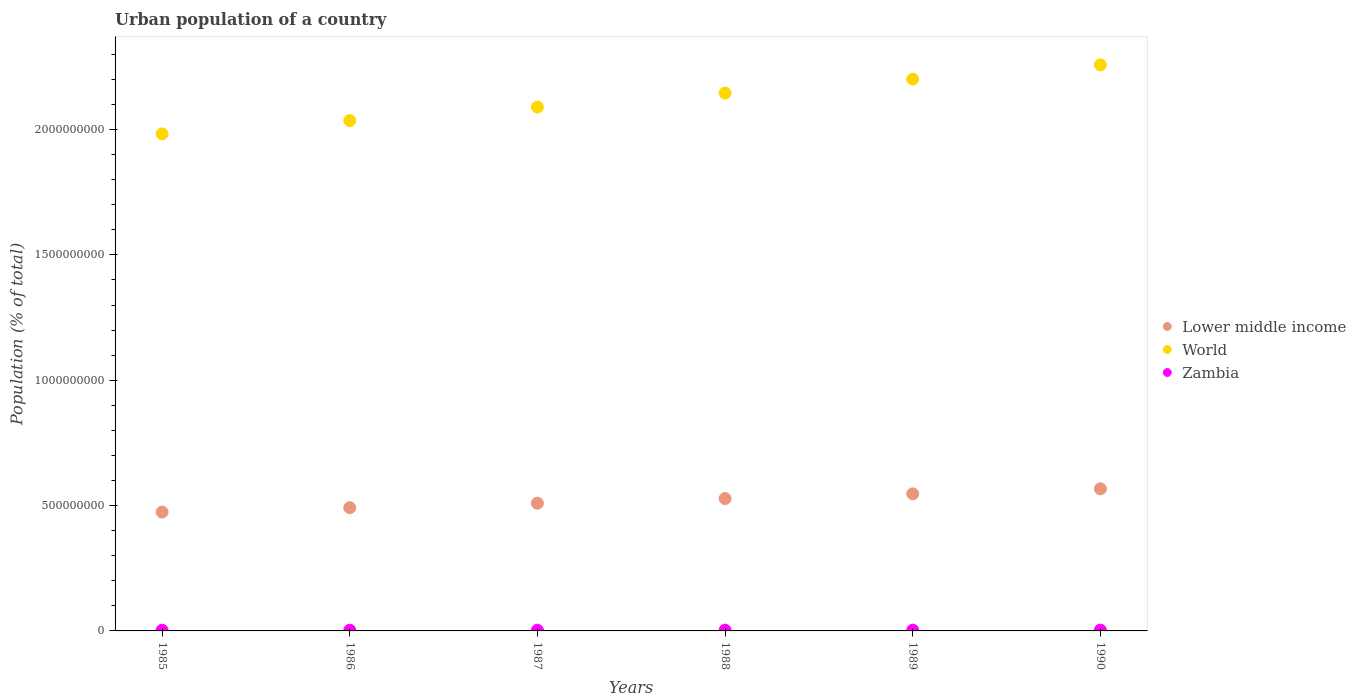How many different coloured dotlines are there?
Make the answer very short. 3. Is the number of dotlines equal to the number of legend labels?
Your response must be concise. Yes. What is the urban population in World in 1985?
Your response must be concise. 1.98e+09. Across all years, what is the maximum urban population in World?
Offer a terse response. 2.26e+09. Across all years, what is the minimum urban population in World?
Offer a terse response. 1.98e+09. In which year was the urban population in World maximum?
Provide a short and direct response. 1990. In which year was the urban population in World minimum?
Make the answer very short. 1985. What is the total urban population in Zambia in the graph?
Make the answer very short. 1.80e+07. What is the difference between the urban population in Zambia in 1985 and that in 1988?
Make the answer very short. -2.58e+05. What is the difference between the urban population in World in 1990 and the urban population in Zambia in 1987?
Provide a succinct answer. 2.26e+09. What is the average urban population in Lower middle income per year?
Make the answer very short. 5.19e+08. In the year 1988, what is the difference between the urban population in Zambia and urban population in Lower middle income?
Provide a short and direct response. -5.25e+08. In how many years, is the urban population in World greater than 2200000000 %?
Your answer should be compact. 2. What is the ratio of the urban population in World in 1985 to that in 1986?
Your answer should be very brief. 0.97. Is the urban population in Zambia in 1989 less than that in 1990?
Ensure brevity in your answer.  Yes. Is the difference between the urban population in Zambia in 1988 and 1990 greater than the difference between the urban population in Lower middle income in 1988 and 1990?
Give a very brief answer. Yes. What is the difference between the highest and the second highest urban population in World?
Provide a succinct answer. 5.70e+07. What is the difference between the highest and the lowest urban population in Lower middle income?
Keep it short and to the point. 9.26e+07. Does the urban population in Lower middle income monotonically increase over the years?
Give a very brief answer. Yes. Is the urban population in Lower middle income strictly greater than the urban population in World over the years?
Provide a succinct answer. No. How many years are there in the graph?
Provide a short and direct response. 6. Are the values on the major ticks of Y-axis written in scientific E-notation?
Your answer should be very brief. No. Does the graph contain any zero values?
Your response must be concise. No. Does the graph contain grids?
Your answer should be very brief. No. How are the legend labels stacked?
Offer a very short reply. Vertical. What is the title of the graph?
Your answer should be very brief. Urban population of a country. Does "Italy" appear as one of the legend labels in the graph?
Provide a short and direct response. No. What is the label or title of the Y-axis?
Give a very brief answer. Population (% of total). What is the Population (% of total) of Lower middle income in 1985?
Make the answer very short. 4.74e+08. What is the Population (% of total) of World in 1985?
Keep it short and to the point. 1.98e+09. What is the Population (% of total) in Zambia in 1985?
Your response must be concise. 2.78e+06. What is the Population (% of total) of Lower middle income in 1986?
Provide a succinct answer. 4.92e+08. What is the Population (% of total) of World in 1986?
Provide a succinct answer. 2.04e+09. What is the Population (% of total) in Zambia in 1986?
Provide a short and direct response. 2.87e+06. What is the Population (% of total) in Lower middle income in 1987?
Ensure brevity in your answer.  5.10e+08. What is the Population (% of total) of World in 1987?
Keep it short and to the point. 2.09e+09. What is the Population (% of total) in Zambia in 1987?
Keep it short and to the point. 2.95e+06. What is the Population (% of total) in Lower middle income in 1988?
Make the answer very short. 5.28e+08. What is the Population (% of total) in World in 1988?
Keep it short and to the point. 2.15e+09. What is the Population (% of total) of Zambia in 1988?
Ensure brevity in your answer.  3.04e+06. What is the Population (% of total) in Lower middle income in 1989?
Offer a terse response. 5.47e+08. What is the Population (% of total) in World in 1989?
Give a very brief answer. 2.20e+09. What is the Population (% of total) of Zambia in 1989?
Give a very brief answer. 3.13e+06. What is the Population (% of total) in Lower middle income in 1990?
Your answer should be compact. 5.67e+08. What is the Population (% of total) of World in 1990?
Ensure brevity in your answer.  2.26e+09. What is the Population (% of total) of Zambia in 1990?
Your answer should be compact. 3.21e+06. Across all years, what is the maximum Population (% of total) of Lower middle income?
Provide a succinct answer. 5.67e+08. Across all years, what is the maximum Population (% of total) in World?
Your answer should be very brief. 2.26e+09. Across all years, what is the maximum Population (% of total) in Zambia?
Ensure brevity in your answer.  3.21e+06. Across all years, what is the minimum Population (% of total) in Lower middle income?
Your response must be concise. 4.74e+08. Across all years, what is the minimum Population (% of total) in World?
Your answer should be compact. 1.98e+09. Across all years, what is the minimum Population (% of total) in Zambia?
Offer a terse response. 2.78e+06. What is the total Population (% of total) in Lower middle income in the graph?
Provide a succinct answer. 3.12e+09. What is the total Population (% of total) in World in the graph?
Offer a very short reply. 1.27e+1. What is the total Population (% of total) of Zambia in the graph?
Make the answer very short. 1.80e+07. What is the difference between the Population (% of total) of Lower middle income in 1985 and that in 1986?
Offer a terse response. -1.75e+07. What is the difference between the Population (% of total) of World in 1985 and that in 1986?
Provide a short and direct response. -5.29e+07. What is the difference between the Population (% of total) of Zambia in 1985 and that in 1986?
Offer a terse response. -8.58e+04. What is the difference between the Population (% of total) in Lower middle income in 1985 and that in 1987?
Offer a terse response. -3.55e+07. What is the difference between the Population (% of total) of World in 1985 and that in 1987?
Your response must be concise. -1.07e+08. What is the difference between the Population (% of total) of Zambia in 1985 and that in 1987?
Make the answer very short. -1.72e+05. What is the difference between the Population (% of total) of Lower middle income in 1985 and that in 1988?
Make the answer very short. -5.39e+07. What is the difference between the Population (% of total) of World in 1985 and that in 1988?
Your answer should be very brief. -1.63e+08. What is the difference between the Population (% of total) of Zambia in 1985 and that in 1988?
Your answer should be very brief. -2.58e+05. What is the difference between the Population (% of total) of Lower middle income in 1985 and that in 1989?
Give a very brief answer. -7.26e+07. What is the difference between the Population (% of total) in World in 1985 and that in 1989?
Offer a very short reply. -2.18e+08. What is the difference between the Population (% of total) of Zambia in 1985 and that in 1989?
Ensure brevity in your answer.  -3.43e+05. What is the difference between the Population (% of total) in Lower middle income in 1985 and that in 1990?
Provide a short and direct response. -9.26e+07. What is the difference between the Population (% of total) in World in 1985 and that in 1990?
Your answer should be very brief. -2.75e+08. What is the difference between the Population (% of total) in Zambia in 1985 and that in 1990?
Provide a short and direct response. -4.26e+05. What is the difference between the Population (% of total) in Lower middle income in 1986 and that in 1987?
Make the answer very short. -1.80e+07. What is the difference between the Population (% of total) of World in 1986 and that in 1987?
Make the answer very short. -5.40e+07. What is the difference between the Population (% of total) in Zambia in 1986 and that in 1987?
Make the answer very short. -8.61e+04. What is the difference between the Population (% of total) of Lower middle income in 1986 and that in 1988?
Your answer should be compact. -3.64e+07. What is the difference between the Population (% of total) in World in 1986 and that in 1988?
Your response must be concise. -1.10e+08. What is the difference between the Population (% of total) in Zambia in 1986 and that in 1988?
Ensure brevity in your answer.  -1.72e+05. What is the difference between the Population (% of total) of Lower middle income in 1986 and that in 1989?
Offer a terse response. -5.51e+07. What is the difference between the Population (% of total) in World in 1986 and that in 1989?
Ensure brevity in your answer.  -1.65e+08. What is the difference between the Population (% of total) in Zambia in 1986 and that in 1989?
Your response must be concise. -2.57e+05. What is the difference between the Population (% of total) in Lower middle income in 1986 and that in 1990?
Offer a terse response. -7.51e+07. What is the difference between the Population (% of total) in World in 1986 and that in 1990?
Your response must be concise. -2.22e+08. What is the difference between the Population (% of total) of Zambia in 1986 and that in 1990?
Your answer should be compact. -3.41e+05. What is the difference between the Population (% of total) in Lower middle income in 1987 and that in 1988?
Give a very brief answer. -1.84e+07. What is the difference between the Population (% of total) in World in 1987 and that in 1988?
Give a very brief answer. -5.59e+07. What is the difference between the Population (% of total) in Zambia in 1987 and that in 1988?
Make the answer very short. -8.59e+04. What is the difference between the Population (% of total) in Lower middle income in 1987 and that in 1989?
Give a very brief answer. -3.71e+07. What is the difference between the Population (% of total) in World in 1987 and that in 1989?
Your answer should be very brief. -1.11e+08. What is the difference between the Population (% of total) of Zambia in 1987 and that in 1989?
Offer a terse response. -1.71e+05. What is the difference between the Population (% of total) of Lower middle income in 1987 and that in 1990?
Your response must be concise. -5.71e+07. What is the difference between the Population (% of total) in World in 1987 and that in 1990?
Provide a short and direct response. -1.69e+08. What is the difference between the Population (% of total) of Zambia in 1987 and that in 1990?
Your answer should be compact. -2.54e+05. What is the difference between the Population (% of total) in Lower middle income in 1988 and that in 1989?
Make the answer very short. -1.87e+07. What is the difference between the Population (% of total) of World in 1988 and that in 1989?
Provide a short and direct response. -5.56e+07. What is the difference between the Population (% of total) of Zambia in 1988 and that in 1989?
Provide a short and direct response. -8.49e+04. What is the difference between the Population (% of total) of Lower middle income in 1988 and that in 1990?
Offer a very short reply. -3.87e+07. What is the difference between the Population (% of total) in World in 1988 and that in 1990?
Offer a terse response. -1.13e+08. What is the difference between the Population (% of total) in Zambia in 1988 and that in 1990?
Make the answer very short. -1.69e+05. What is the difference between the Population (% of total) of Lower middle income in 1989 and that in 1990?
Your answer should be very brief. -2.01e+07. What is the difference between the Population (% of total) of World in 1989 and that in 1990?
Make the answer very short. -5.70e+07. What is the difference between the Population (% of total) of Zambia in 1989 and that in 1990?
Your response must be concise. -8.36e+04. What is the difference between the Population (% of total) of Lower middle income in 1985 and the Population (% of total) of World in 1986?
Your response must be concise. -1.56e+09. What is the difference between the Population (% of total) in Lower middle income in 1985 and the Population (% of total) in Zambia in 1986?
Your response must be concise. 4.71e+08. What is the difference between the Population (% of total) of World in 1985 and the Population (% of total) of Zambia in 1986?
Provide a succinct answer. 1.98e+09. What is the difference between the Population (% of total) of Lower middle income in 1985 and the Population (% of total) of World in 1987?
Your answer should be very brief. -1.62e+09. What is the difference between the Population (% of total) of Lower middle income in 1985 and the Population (% of total) of Zambia in 1987?
Ensure brevity in your answer.  4.71e+08. What is the difference between the Population (% of total) of World in 1985 and the Population (% of total) of Zambia in 1987?
Your response must be concise. 1.98e+09. What is the difference between the Population (% of total) of Lower middle income in 1985 and the Population (% of total) of World in 1988?
Offer a terse response. -1.67e+09. What is the difference between the Population (% of total) in Lower middle income in 1985 and the Population (% of total) in Zambia in 1988?
Your answer should be compact. 4.71e+08. What is the difference between the Population (% of total) of World in 1985 and the Population (% of total) of Zambia in 1988?
Make the answer very short. 1.98e+09. What is the difference between the Population (% of total) of Lower middle income in 1985 and the Population (% of total) of World in 1989?
Make the answer very short. -1.73e+09. What is the difference between the Population (% of total) of Lower middle income in 1985 and the Population (% of total) of Zambia in 1989?
Your answer should be very brief. 4.71e+08. What is the difference between the Population (% of total) of World in 1985 and the Population (% of total) of Zambia in 1989?
Your answer should be compact. 1.98e+09. What is the difference between the Population (% of total) of Lower middle income in 1985 and the Population (% of total) of World in 1990?
Provide a succinct answer. -1.78e+09. What is the difference between the Population (% of total) in Lower middle income in 1985 and the Population (% of total) in Zambia in 1990?
Give a very brief answer. 4.71e+08. What is the difference between the Population (% of total) in World in 1985 and the Population (% of total) in Zambia in 1990?
Provide a short and direct response. 1.98e+09. What is the difference between the Population (% of total) of Lower middle income in 1986 and the Population (% of total) of World in 1987?
Offer a terse response. -1.60e+09. What is the difference between the Population (% of total) in Lower middle income in 1986 and the Population (% of total) in Zambia in 1987?
Offer a terse response. 4.89e+08. What is the difference between the Population (% of total) of World in 1986 and the Population (% of total) of Zambia in 1987?
Provide a succinct answer. 2.03e+09. What is the difference between the Population (% of total) in Lower middle income in 1986 and the Population (% of total) in World in 1988?
Provide a succinct answer. -1.65e+09. What is the difference between the Population (% of total) in Lower middle income in 1986 and the Population (% of total) in Zambia in 1988?
Offer a terse response. 4.89e+08. What is the difference between the Population (% of total) of World in 1986 and the Population (% of total) of Zambia in 1988?
Offer a terse response. 2.03e+09. What is the difference between the Population (% of total) in Lower middle income in 1986 and the Population (% of total) in World in 1989?
Your answer should be compact. -1.71e+09. What is the difference between the Population (% of total) of Lower middle income in 1986 and the Population (% of total) of Zambia in 1989?
Offer a very short reply. 4.88e+08. What is the difference between the Population (% of total) of World in 1986 and the Population (% of total) of Zambia in 1989?
Provide a succinct answer. 2.03e+09. What is the difference between the Population (% of total) of Lower middle income in 1986 and the Population (% of total) of World in 1990?
Your answer should be compact. -1.77e+09. What is the difference between the Population (% of total) of Lower middle income in 1986 and the Population (% of total) of Zambia in 1990?
Provide a short and direct response. 4.88e+08. What is the difference between the Population (% of total) of World in 1986 and the Population (% of total) of Zambia in 1990?
Provide a short and direct response. 2.03e+09. What is the difference between the Population (% of total) in Lower middle income in 1987 and the Population (% of total) in World in 1988?
Ensure brevity in your answer.  -1.64e+09. What is the difference between the Population (% of total) in Lower middle income in 1987 and the Population (% of total) in Zambia in 1988?
Provide a short and direct response. 5.07e+08. What is the difference between the Population (% of total) of World in 1987 and the Population (% of total) of Zambia in 1988?
Your answer should be very brief. 2.09e+09. What is the difference between the Population (% of total) in Lower middle income in 1987 and the Population (% of total) in World in 1989?
Make the answer very short. -1.69e+09. What is the difference between the Population (% of total) in Lower middle income in 1987 and the Population (% of total) in Zambia in 1989?
Give a very brief answer. 5.06e+08. What is the difference between the Population (% of total) in World in 1987 and the Population (% of total) in Zambia in 1989?
Your response must be concise. 2.09e+09. What is the difference between the Population (% of total) of Lower middle income in 1987 and the Population (% of total) of World in 1990?
Make the answer very short. -1.75e+09. What is the difference between the Population (% of total) of Lower middle income in 1987 and the Population (% of total) of Zambia in 1990?
Provide a short and direct response. 5.06e+08. What is the difference between the Population (% of total) in World in 1987 and the Population (% of total) in Zambia in 1990?
Your response must be concise. 2.09e+09. What is the difference between the Population (% of total) in Lower middle income in 1988 and the Population (% of total) in World in 1989?
Provide a succinct answer. -1.67e+09. What is the difference between the Population (% of total) in Lower middle income in 1988 and the Population (% of total) in Zambia in 1989?
Offer a very short reply. 5.25e+08. What is the difference between the Population (% of total) in World in 1988 and the Population (% of total) in Zambia in 1989?
Your response must be concise. 2.14e+09. What is the difference between the Population (% of total) in Lower middle income in 1988 and the Population (% of total) in World in 1990?
Keep it short and to the point. -1.73e+09. What is the difference between the Population (% of total) of Lower middle income in 1988 and the Population (% of total) of Zambia in 1990?
Offer a very short reply. 5.25e+08. What is the difference between the Population (% of total) of World in 1988 and the Population (% of total) of Zambia in 1990?
Your answer should be compact. 2.14e+09. What is the difference between the Population (% of total) in Lower middle income in 1989 and the Population (% of total) in World in 1990?
Offer a terse response. -1.71e+09. What is the difference between the Population (% of total) of Lower middle income in 1989 and the Population (% of total) of Zambia in 1990?
Ensure brevity in your answer.  5.43e+08. What is the difference between the Population (% of total) in World in 1989 and the Population (% of total) in Zambia in 1990?
Ensure brevity in your answer.  2.20e+09. What is the average Population (% of total) in Lower middle income per year?
Your answer should be compact. 5.19e+08. What is the average Population (% of total) in World per year?
Ensure brevity in your answer.  2.12e+09. What is the average Population (% of total) of Zambia per year?
Offer a very short reply. 3.00e+06. In the year 1985, what is the difference between the Population (% of total) in Lower middle income and Population (% of total) in World?
Keep it short and to the point. -1.51e+09. In the year 1985, what is the difference between the Population (% of total) of Lower middle income and Population (% of total) of Zambia?
Ensure brevity in your answer.  4.71e+08. In the year 1985, what is the difference between the Population (% of total) in World and Population (% of total) in Zambia?
Provide a short and direct response. 1.98e+09. In the year 1986, what is the difference between the Population (% of total) of Lower middle income and Population (% of total) of World?
Keep it short and to the point. -1.54e+09. In the year 1986, what is the difference between the Population (% of total) of Lower middle income and Population (% of total) of Zambia?
Your answer should be compact. 4.89e+08. In the year 1986, what is the difference between the Population (% of total) of World and Population (% of total) of Zambia?
Your answer should be compact. 2.03e+09. In the year 1987, what is the difference between the Population (% of total) in Lower middle income and Population (% of total) in World?
Keep it short and to the point. -1.58e+09. In the year 1987, what is the difference between the Population (% of total) in Lower middle income and Population (% of total) in Zambia?
Ensure brevity in your answer.  5.07e+08. In the year 1987, what is the difference between the Population (% of total) in World and Population (% of total) in Zambia?
Provide a short and direct response. 2.09e+09. In the year 1988, what is the difference between the Population (% of total) of Lower middle income and Population (% of total) of World?
Provide a succinct answer. -1.62e+09. In the year 1988, what is the difference between the Population (% of total) in Lower middle income and Population (% of total) in Zambia?
Your answer should be compact. 5.25e+08. In the year 1988, what is the difference between the Population (% of total) of World and Population (% of total) of Zambia?
Ensure brevity in your answer.  2.14e+09. In the year 1989, what is the difference between the Population (% of total) in Lower middle income and Population (% of total) in World?
Keep it short and to the point. -1.65e+09. In the year 1989, what is the difference between the Population (% of total) in Lower middle income and Population (% of total) in Zambia?
Provide a short and direct response. 5.44e+08. In the year 1989, what is the difference between the Population (% of total) of World and Population (% of total) of Zambia?
Ensure brevity in your answer.  2.20e+09. In the year 1990, what is the difference between the Population (% of total) in Lower middle income and Population (% of total) in World?
Your response must be concise. -1.69e+09. In the year 1990, what is the difference between the Population (% of total) of Lower middle income and Population (% of total) of Zambia?
Your answer should be very brief. 5.64e+08. In the year 1990, what is the difference between the Population (% of total) of World and Population (% of total) of Zambia?
Provide a succinct answer. 2.25e+09. What is the ratio of the Population (% of total) of Lower middle income in 1985 to that in 1986?
Offer a terse response. 0.96. What is the ratio of the Population (% of total) of World in 1985 to that in 1986?
Your response must be concise. 0.97. What is the ratio of the Population (% of total) in Zambia in 1985 to that in 1986?
Your response must be concise. 0.97. What is the ratio of the Population (% of total) of Lower middle income in 1985 to that in 1987?
Provide a succinct answer. 0.93. What is the ratio of the Population (% of total) in World in 1985 to that in 1987?
Make the answer very short. 0.95. What is the ratio of the Population (% of total) of Zambia in 1985 to that in 1987?
Give a very brief answer. 0.94. What is the ratio of the Population (% of total) in Lower middle income in 1985 to that in 1988?
Provide a succinct answer. 0.9. What is the ratio of the Population (% of total) of World in 1985 to that in 1988?
Ensure brevity in your answer.  0.92. What is the ratio of the Population (% of total) of Zambia in 1985 to that in 1988?
Your response must be concise. 0.92. What is the ratio of the Population (% of total) in Lower middle income in 1985 to that in 1989?
Offer a terse response. 0.87. What is the ratio of the Population (% of total) of World in 1985 to that in 1989?
Ensure brevity in your answer.  0.9. What is the ratio of the Population (% of total) of Zambia in 1985 to that in 1989?
Give a very brief answer. 0.89. What is the ratio of the Population (% of total) of Lower middle income in 1985 to that in 1990?
Your answer should be very brief. 0.84. What is the ratio of the Population (% of total) of World in 1985 to that in 1990?
Ensure brevity in your answer.  0.88. What is the ratio of the Population (% of total) in Zambia in 1985 to that in 1990?
Keep it short and to the point. 0.87. What is the ratio of the Population (% of total) in Lower middle income in 1986 to that in 1987?
Offer a terse response. 0.96. What is the ratio of the Population (% of total) of World in 1986 to that in 1987?
Provide a short and direct response. 0.97. What is the ratio of the Population (% of total) in Zambia in 1986 to that in 1987?
Your answer should be very brief. 0.97. What is the ratio of the Population (% of total) in Lower middle income in 1986 to that in 1988?
Keep it short and to the point. 0.93. What is the ratio of the Population (% of total) in World in 1986 to that in 1988?
Your response must be concise. 0.95. What is the ratio of the Population (% of total) of Zambia in 1986 to that in 1988?
Provide a succinct answer. 0.94. What is the ratio of the Population (% of total) of Lower middle income in 1986 to that in 1989?
Offer a very short reply. 0.9. What is the ratio of the Population (% of total) of World in 1986 to that in 1989?
Offer a very short reply. 0.92. What is the ratio of the Population (% of total) of Zambia in 1986 to that in 1989?
Make the answer very short. 0.92. What is the ratio of the Population (% of total) in Lower middle income in 1986 to that in 1990?
Ensure brevity in your answer.  0.87. What is the ratio of the Population (% of total) of World in 1986 to that in 1990?
Provide a short and direct response. 0.9. What is the ratio of the Population (% of total) in Zambia in 1986 to that in 1990?
Keep it short and to the point. 0.89. What is the ratio of the Population (% of total) in Lower middle income in 1987 to that in 1988?
Provide a short and direct response. 0.97. What is the ratio of the Population (% of total) in World in 1987 to that in 1988?
Make the answer very short. 0.97. What is the ratio of the Population (% of total) in Zambia in 1987 to that in 1988?
Your answer should be very brief. 0.97. What is the ratio of the Population (% of total) of Lower middle income in 1987 to that in 1989?
Offer a very short reply. 0.93. What is the ratio of the Population (% of total) of World in 1987 to that in 1989?
Your response must be concise. 0.95. What is the ratio of the Population (% of total) of Zambia in 1987 to that in 1989?
Give a very brief answer. 0.95. What is the ratio of the Population (% of total) in Lower middle income in 1987 to that in 1990?
Your answer should be very brief. 0.9. What is the ratio of the Population (% of total) of World in 1987 to that in 1990?
Ensure brevity in your answer.  0.93. What is the ratio of the Population (% of total) of Zambia in 1987 to that in 1990?
Provide a short and direct response. 0.92. What is the ratio of the Population (% of total) in Lower middle income in 1988 to that in 1989?
Your answer should be very brief. 0.97. What is the ratio of the Population (% of total) of World in 1988 to that in 1989?
Give a very brief answer. 0.97. What is the ratio of the Population (% of total) of Zambia in 1988 to that in 1989?
Offer a very short reply. 0.97. What is the ratio of the Population (% of total) in Lower middle income in 1988 to that in 1990?
Provide a short and direct response. 0.93. What is the ratio of the Population (% of total) of World in 1988 to that in 1990?
Your answer should be compact. 0.95. What is the ratio of the Population (% of total) in Zambia in 1988 to that in 1990?
Offer a very short reply. 0.95. What is the ratio of the Population (% of total) of Lower middle income in 1989 to that in 1990?
Give a very brief answer. 0.96. What is the ratio of the Population (% of total) in World in 1989 to that in 1990?
Ensure brevity in your answer.  0.97. What is the ratio of the Population (% of total) of Zambia in 1989 to that in 1990?
Give a very brief answer. 0.97. What is the difference between the highest and the second highest Population (% of total) in Lower middle income?
Offer a very short reply. 2.01e+07. What is the difference between the highest and the second highest Population (% of total) in World?
Provide a succinct answer. 5.70e+07. What is the difference between the highest and the second highest Population (% of total) in Zambia?
Make the answer very short. 8.36e+04. What is the difference between the highest and the lowest Population (% of total) in Lower middle income?
Your response must be concise. 9.26e+07. What is the difference between the highest and the lowest Population (% of total) in World?
Offer a very short reply. 2.75e+08. What is the difference between the highest and the lowest Population (% of total) in Zambia?
Offer a terse response. 4.26e+05. 